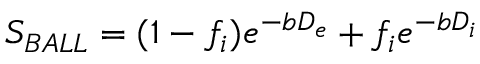<formula> <loc_0><loc_0><loc_500><loc_500>S _ { B A L L } = ( 1 - f _ { i } ) e ^ { - b D _ { e } } + f _ { i } e ^ { - b D _ { i } }</formula> 